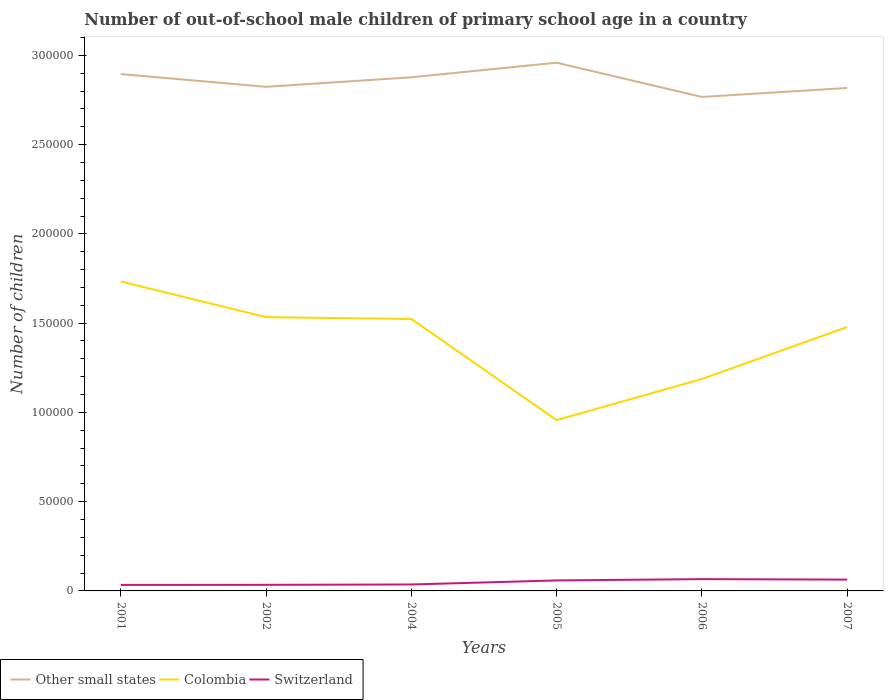How many different coloured lines are there?
Offer a terse response. 3. Is the number of lines equal to the number of legend labels?
Give a very brief answer. Yes. Across all years, what is the maximum number of out-of-school male children in Colombia?
Provide a short and direct response. 9.57e+04. What is the total number of out-of-school male children in Colombia in the graph?
Your response must be concise. 5551. What is the difference between the highest and the second highest number of out-of-school male children in Other small states?
Offer a very short reply. 1.92e+04. How many lines are there?
Provide a succinct answer. 3. How many years are there in the graph?
Give a very brief answer. 6. What is the difference between two consecutive major ticks on the Y-axis?
Make the answer very short. 5.00e+04. Are the values on the major ticks of Y-axis written in scientific E-notation?
Your response must be concise. No. Does the graph contain any zero values?
Your answer should be compact. No. How many legend labels are there?
Offer a terse response. 3. What is the title of the graph?
Offer a terse response. Number of out-of-school male children of primary school age in a country. Does "Lithuania" appear as one of the legend labels in the graph?
Keep it short and to the point. No. What is the label or title of the X-axis?
Ensure brevity in your answer.  Years. What is the label or title of the Y-axis?
Give a very brief answer. Number of children. What is the Number of children in Other small states in 2001?
Offer a terse response. 2.90e+05. What is the Number of children of Colombia in 2001?
Offer a very short reply. 1.73e+05. What is the Number of children of Switzerland in 2001?
Provide a succinct answer. 3363. What is the Number of children in Other small states in 2002?
Keep it short and to the point. 2.82e+05. What is the Number of children in Colombia in 2002?
Your answer should be very brief. 1.53e+05. What is the Number of children in Switzerland in 2002?
Make the answer very short. 3410. What is the Number of children in Other small states in 2004?
Offer a very short reply. 2.88e+05. What is the Number of children in Colombia in 2004?
Your response must be concise. 1.52e+05. What is the Number of children in Switzerland in 2004?
Keep it short and to the point. 3605. What is the Number of children of Other small states in 2005?
Offer a terse response. 2.96e+05. What is the Number of children of Colombia in 2005?
Make the answer very short. 9.57e+04. What is the Number of children of Switzerland in 2005?
Offer a very short reply. 5885. What is the Number of children of Other small states in 2006?
Make the answer very short. 2.77e+05. What is the Number of children of Colombia in 2006?
Provide a short and direct response. 1.19e+05. What is the Number of children of Switzerland in 2006?
Offer a terse response. 6611. What is the Number of children in Other small states in 2007?
Provide a succinct answer. 2.82e+05. What is the Number of children in Colombia in 2007?
Offer a very short reply. 1.48e+05. What is the Number of children in Switzerland in 2007?
Your answer should be very brief. 6335. Across all years, what is the maximum Number of children of Other small states?
Your answer should be compact. 2.96e+05. Across all years, what is the maximum Number of children of Colombia?
Offer a very short reply. 1.73e+05. Across all years, what is the maximum Number of children in Switzerland?
Ensure brevity in your answer.  6611. Across all years, what is the minimum Number of children in Other small states?
Provide a succinct answer. 2.77e+05. Across all years, what is the minimum Number of children of Colombia?
Your answer should be very brief. 9.57e+04. Across all years, what is the minimum Number of children in Switzerland?
Make the answer very short. 3363. What is the total Number of children of Other small states in the graph?
Provide a short and direct response. 1.71e+06. What is the total Number of children in Colombia in the graph?
Offer a terse response. 8.41e+05. What is the total Number of children of Switzerland in the graph?
Keep it short and to the point. 2.92e+04. What is the difference between the Number of children of Other small states in 2001 and that in 2002?
Ensure brevity in your answer.  7131. What is the difference between the Number of children of Colombia in 2001 and that in 2002?
Your answer should be very brief. 2.00e+04. What is the difference between the Number of children of Switzerland in 2001 and that in 2002?
Ensure brevity in your answer.  -47. What is the difference between the Number of children in Other small states in 2001 and that in 2004?
Provide a succinct answer. 1800. What is the difference between the Number of children of Colombia in 2001 and that in 2004?
Ensure brevity in your answer.  2.10e+04. What is the difference between the Number of children of Switzerland in 2001 and that in 2004?
Give a very brief answer. -242. What is the difference between the Number of children in Other small states in 2001 and that in 2005?
Keep it short and to the point. -6383. What is the difference between the Number of children in Colombia in 2001 and that in 2005?
Give a very brief answer. 7.77e+04. What is the difference between the Number of children of Switzerland in 2001 and that in 2005?
Keep it short and to the point. -2522. What is the difference between the Number of children of Other small states in 2001 and that in 2006?
Provide a succinct answer. 1.28e+04. What is the difference between the Number of children in Colombia in 2001 and that in 2006?
Your answer should be very brief. 5.46e+04. What is the difference between the Number of children in Switzerland in 2001 and that in 2006?
Provide a succinct answer. -3248. What is the difference between the Number of children in Other small states in 2001 and that in 2007?
Your answer should be compact. 7787. What is the difference between the Number of children of Colombia in 2001 and that in 2007?
Your response must be concise. 2.56e+04. What is the difference between the Number of children of Switzerland in 2001 and that in 2007?
Keep it short and to the point. -2972. What is the difference between the Number of children in Other small states in 2002 and that in 2004?
Offer a very short reply. -5331. What is the difference between the Number of children in Colombia in 2002 and that in 2004?
Provide a short and direct response. 1021. What is the difference between the Number of children in Switzerland in 2002 and that in 2004?
Offer a very short reply. -195. What is the difference between the Number of children in Other small states in 2002 and that in 2005?
Your answer should be very brief. -1.35e+04. What is the difference between the Number of children in Colombia in 2002 and that in 2005?
Ensure brevity in your answer.  5.77e+04. What is the difference between the Number of children in Switzerland in 2002 and that in 2005?
Offer a terse response. -2475. What is the difference between the Number of children in Other small states in 2002 and that in 2006?
Keep it short and to the point. 5676. What is the difference between the Number of children of Colombia in 2002 and that in 2006?
Give a very brief answer. 3.46e+04. What is the difference between the Number of children in Switzerland in 2002 and that in 2006?
Make the answer very short. -3201. What is the difference between the Number of children of Other small states in 2002 and that in 2007?
Offer a terse response. 656. What is the difference between the Number of children of Colombia in 2002 and that in 2007?
Offer a terse response. 5551. What is the difference between the Number of children of Switzerland in 2002 and that in 2007?
Your answer should be compact. -2925. What is the difference between the Number of children of Other small states in 2004 and that in 2005?
Offer a terse response. -8183. What is the difference between the Number of children in Colombia in 2004 and that in 2005?
Make the answer very short. 5.67e+04. What is the difference between the Number of children of Switzerland in 2004 and that in 2005?
Your answer should be very brief. -2280. What is the difference between the Number of children of Other small states in 2004 and that in 2006?
Keep it short and to the point. 1.10e+04. What is the difference between the Number of children in Colombia in 2004 and that in 2006?
Your answer should be compact. 3.36e+04. What is the difference between the Number of children of Switzerland in 2004 and that in 2006?
Make the answer very short. -3006. What is the difference between the Number of children in Other small states in 2004 and that in 2007?
Offer a terse response. 5987. What is the difference between the Number of children in Colombia in 2004 and that in 2007?
Your response must be concise. 4530. What is the difference between the Number of children of Switzerland in 2004 and that in 2007?
Keep it short and to the point. -2730. What is the difference between the Number of children in Other small states in 2005 and that in 2006?
Your answer should be compact. 1.92e+04. What is the difference between the Number of children of Colombia in 2005 and that in 2006?
Make the answer very short. -2.30e+04. What is the difference between the Number of children of Switzerland in 2005 and that in 2006?
Your answer should be compact. -726. What is the difference between the Number of children of Other small states in 2005 and that in 2007?
Provide a succinct answer. 1.42e+04. What is the difference between the Number of children of Colombia in 2005 and that in 2007?
Make the answer very short. -5.21e+04. What is the difference between the Number of children of Switzerland in 2005 and that in 2007?
Offer a terse response. -450. What is the difference between the Number of children in Other small states in 2006 and that in 2007?
Ensure brevity in your answer.  -5020. What is the difference between the Number of children of Colombia in 2006 and that in 2007?
Ensure brevity in your answer.  -2.91e+04. What is the difference between the Number of children in Switzerland in 2006 and that in 2007?
Keep it short and to the point. 276. What is the difference between the Number of children of Other small states in 2001 and the Number of children of Colombia in 2002?
Offer a very short reply. 1.36e+05. What is the difference between the Number of children in Other small states in 2001 and the Number of children in Switzerland in 2002?
Provide a short and direct response. 2.86e+05. What is the difference between the Number of children in Colombia in 2001 and the Number of children in Switzerland in 2002?
Your response must be concise. 1.70e+05. What is the difference between the Number of children of Other small states in 2001 and the Number of children of Colombia in 2004?
Your answer should be compact. 1.37e+05. What is the difference between the Number of children in Other small states in 2001 and the Number of children in Switzerland in 2004?
Provide a succinct answer. 2.86e+05. What is the difference between the Number of children of Colombia in 2001 and the Number of children of Switzerland in 2004?
Offer a very short reply. 1.70e+05. What is the difference between the Number of children in Other small states in 2001 and the Number of children in Colombia in 2005?
Ensure brevity in your answer.  1.94e+05. What is the difference between the Number of children of Other small states in 2001 and the Number of children of Switzerland in 2005?
Offer a very short reply. 2.84e+05. What is the difference between the Number of children of Colombia in 2001 and the Number of children of Switzerland in 2005?
Your answer should be compact. 1.67e+05. What is the difference between the Number of children in Other small states in 2001 and the Number of children in Colombia in 2006?
Provide a succinct answer. 1.71e+05. What is the difference between the Number of children in Other small states in 2001 and the Number of children in Switzerland in 2006?
Provide a short and direct response. 2.83e+05. What is the difference between the Number of children in Colombia in 2001 and the Number of children in Switzerland in 2006?
Your answer should be compact. 1.67e+05. What is the difference between the Number of children in Other small states in 2001 and the Number of children in Colombia in 2007?
Your answer should be very brief. 1.42e+05. What is the difference between the Number of children of Other small states in 2001 and the Number of children of Switzerland in 2007?
Give a very brief answer. 2.83e+05. What is the difference between the Number of children in Colombia in 2001 and the Number of children in Switzerland in 2007?
Provide a short and direct response. 1.67e+05. What is the difference between the Number of children of Other small states in 2002 and the Number of children of Colombia in 2004?
Offer a very short reply. 1.30e+05. What is the difference between the Number of children of Other small states in 2002 and the Number of children of Switzerland in 2004?
Give a very brief answer. 2.79e+05. What is the difference between the Number of children in Colombia in 2002 and the Number of children in Switzerland in 2004?
Provide a succinct answer. 1.50e+05. What is the difference between the Number of children in Other small states in 2002 and the Number of children in Colombia in 2005?
Your answer should be compact. 1.87e+05. What is the difference between the Number of children in Other small states in 2002 and the Number of children in Switzerland in 2005?
Your answer should be very brief. 2.76e+05. What is the difference between the Number of children of Colombia in 2002 and the Number of children of Switzerland in 2005?
Give a very brief answer. 1.47e+05. What is the difference between the Number of children of Other small states in 2002 and the Number of children of Colombia in 2006?
Make the answer very short. 1.64e+05. What is the difference between the Number of children of Other small states in 2002 and the Number of children of Switzerland in 2006?
Make the answer very short. 2.76e+05. What is the difference between the Number of children in Colombia in 2002 and the Number of children in Switzerland in 2006?
Give a very brief answer. 1.47e+05. What is the difference between the Number of children in Other small states in 2002 and the Number of children in Colombia in 2007?
Your answer should be very brief. 1.35e+05. What is the difference between the Number of children in Other small states in 2002 and the Number of children in Switzerland in 2007?
Provide a short and direct response. 2.76e+05. What is the difference between the Number of children in Colombia in 2002 and the Number of children in Switzerland in 2007?
Your answer should be very brief. 1.47e+05. What is the difference between the Number of children in Other small states in 2004 and the Number of children in Colombia in 2005?
Your response must be concise. 1.92e+05. What is the difference between the Number of children of Other small states in 2004 and the Number of children of Switzerland in 2005?
Offer a terse response. 2.82e+05. What is the difference between the Number of children in Colombia in 2004 and the Number of children in Switzerland in 2005?
Your response must be concise. 1.46e+05. What is the difference between the Number of children in Other small states in 2004 and the Number of children in Colombia in 2006?
Keep it short and to the point. 1.69e+05. What is the difference between the Number of children in Other small states in 2004 and the Number of children in Switzerland in 2006?
Ensure brevity in your answer.  2.81e+05. What is the difference between the Number of children of Colombia in 2004 and the Number of children of Switzerland in 2006?
Offer a terse response. 1.46e+05. What is the difference between the Number of children in Other small states in 2004 and the Number of children in Colombia in 2007?
Ensure brevity in your answer.  1.40e+05. What is the difference between the Number of children in Other small states in 2004 and the Number of children in Switzerland in 2007?
Provide a short and direct response. 2.81e+05. What is the difference between the Number of children of Colombia in 2004 and the Number of children of Switzerland in 2007?
Offer a terse response. 1.46e+05. What is the difference between the Number of children in Other small states in 2005 and the Number of children in Colombia in 2006?
Give a very brief answer. 1.77e+05. What is the difference between the Number of children of Other small states in 2005 and the Number of children of Switzerland in 2006?
Provide a short and direct response. 2.89e+05. What is the difference between the Number of children in Colombia in 2005 and the Number of children in Switzerland in 2006?
Keep it short and to the point. 8.91e+04. What is the difference between the Number of children of Other small states in 2005 and the Number of children of Colombia in 2007?
Your response must be concise. 1.48e+05. What is the difference between the Number of children of Other small states in 2005 and the Number of children of Switzerland in 2007?
Provide a succinct answer. 2.90e+05. What is the difference between the Number of children of Colombia in 2005 and the Number of children of Switzerland in 2007?
Provide a short and direct response. 8.93e+04. What is the difference between the Number of children in Other small states in 2006 and the Number of children in Colombia in 2007?
Your response must be concise. 1.29e+05. What is the difference between the Number of children in Other small states in 2006 and the Number of children in Switzerland in 2007?
Ensure brevity in your answer.  2.70e+05. What is the difference between the Number of children in Colombia in 2006 and the Number of children in Switzerland in 2007?
Provide a short and direct response. 1.12e+05. What is the average Number of children in Other small states per year?
Your answer should be very brief. 2.86e+05. What is the average Number of children of Colombia per year?
Make the answer very short. 1.40e+05. What is the average Number of children of Switzerland per year?
Your answer should be compact. 4868.17. In the year 2001, what is the difference between the Number of children of Other small states and Number of children of Colombia?
Give a very brief answer. 1.16e+05. In the year 2001, what is the difference between the Number of children of Other small states and Number of children of Switzerland?
Give a very brief answer. 2.86e+05. In the year 2001, what is the difference between the Number of children of Colombia and Number of children of Switzerland?
Keep it short and to the point. 1.70e+05. In the year 2002, what is the difference between the Number of children of Other small states and Number of children of Colombia?
Provide a short and direct response. 1.29e+05. In the year 2002, what is the difference between the Number of children of Other small states and Number of children of Switzerland?
Offer a very short reply. 2.79e+05. In the year 2002, what is the difference between the Number of children in Colombia and Number of children in Switzerland?
Give a very brief answer. 1.50e+05. In the year 2004, what is the difference between the Number of children of Other small states and Number of children of Colombia?
Your answer should be compact. 1.35e+05. In the year 2004, what is the difference between the Number of children of Other small states and Number of children of Switzerland?
Offer a very short reply. 2.84e+05. In the year 2004, what is the difference between the Number of children of Colombia and Number of children of Switzerland?
Provide a short and direct response. 1.49e+05. In the year 2005, what is the difference between the Number of children in Other small states and Number of children in Colombia?
Give a very brief answer. 2.00e+05. In the year 2005, what is the difference between the Number of children of Other small states and Number of children of Switzerland?
Make the answer very short. 2.90e+05. In the year 2005, what is the difference between the Number of children of Colombia and Number of children of Switzerland?
Keep it short and to the point. 8.98e+04. In the year 2006, what is the difference between the Number of children in Other small states and Number of children in Colombia?
Ensure brevity in your answer.  1.58e+05. In the year 2006, what is the difference between the Number of children in Other small states and Number of children in Switzerland?
Give a very brief answer. 2.70e+05. In the year 2006, what is the difference between the Number of children of Colombia and Number of children of Switzerland?
Offer a terse response. 1.12e+05. In the year 2007, what is the difference between the Number of children of Other small states and Number of children of Colombia?
Your response must be concise. 1.34e+05. In the year 2007, what is the difference between the Number of children of Other small states and Number of children of Switzerland?
Make the answer very short. 2.75e+05. In the year 2007, what is the difference between the Number of children in Colombia and Number of children in Switzerland?
Offer a very short reply. 1.41e+05. What is the ratio of the Number of children in Other small states in 2001 to that in 2002?
Give a very brief answer. 1.03. What is the ratio of the Number of children in Colombia in 2001 to that in 2002?
Ensure brevity in your answer.  1.13. What is the ratio of the Number of children of Switzerland in 2001 to that in 2002?
Offer a very short reply. 0.99. What is the ratio of the Number of children of Colombia in 2001 to that in 2004?
Your answer should be compact. 1.14. What is the ratio of the Number of children of Switzerland in 2001 to that in 2004?
Your answer should be compact. 0.93. What is the ratio of the Number of children in Other small states in 2001 to that in 2005?
Your response must be concise. 0.98. What is the ratio of the Number of children of Colombia in 2001 to that in 2005?
Offer a terse response. 1.81. What is the ratio of the Number of children of Switzerland in 2001 to that in 2005?
Make the answer very short. 0.57. What is the ratio of the Number of children of Other small states in 2001 to that in 2006?
Your answer should be very brief. 1.05. What is the ratio of the Number of children of Colombia in 2001 to that in 2006?
Your answer should be compact. 1.46. What is the ratio of the Number of children in Switzerland in 2001 to that in 2006?
Provide a short and direct response. 0.51. What is the ratio of the Number of children in Other small states in 2001 to that in 2007?
Your answer should be compact. 1.03. What is the ratio of the Number of children in Colombia in 2001 to that in 2007?
Offer a terse response. 1.17. What is the ratio of the Number of children in Switzerland in 2001 to that in 2007?
Offer a terse response. 0.53. What is the ratio of the Number of children in Other small states in 2002 to that in 2004?
Provide a succinct answer. 0.98. What is the ratio of the Number of children in Switzerland in 2002 to that in 2004?
Your answer should be compact. 0.95. What is the ratio of the Number of children in Other small states in 2002 to that in 2005?
Provide a short and direct response. 0.95. What is the ratio of the Number of children of Colombia in 2002 to that in 2005?
Provide a short and direct response. 1.6. What is the ratio of the Number of children in Switzerland in 2002 to that in 2005?
Your response must be concise. 0.58. What is the ratio of the Number of children in Other small states in 2002 to that in 2006?
Keep it short and to the point. 1.02. What is the ratio of the Number of children in Colombia in 2002 to that in 2006?
Provide a short and direct response. 1.29. What is the ratio of the Number of children in Switzerland in 2002 to that in 2006?
Provide a succinct answer. 0.52. What is the ratio of the Number of children in Other small states in 2002 to that in 2007?
Your answer should be very brief. 1. What is the ratio of the Number of children of Colombia in 2002 to that in 2007?
Offer a terse response. 1.04. What is the ratio of the Number of children in Switzerland in 2002 to that in 2007?
Your answer should be very brief. 0.54. What is the ratio of the Number of children of Other small states in 2004 to that in 2005?
Provide a succinct answer. 0.97. What is the ratio of the Number of children in Colombia in 2004 to that in 2005?
Provide a succinct answer. 1.59. What is the ratio of the Number of children in Switzerland in 2004 to that in 2005?
Your answer should be compact. 0.61. What is the ratio of the Number of children in Other small states in 2004 to that in 2006?
Keep it short and to the point. 1.04. What is the ratio of the Number of children in Colombia in 2004 to that in 2006?
Offer a very short reply. 1.28. What is the ratio of the Number of children of Switzerland in 2004 to that in 2006?
Provide a succinct answer. 0.55. What is the ratio of the Number of children of Other small states in 2004 to that in 2007?
Offer a terse response. 1.02. What is the ratio of the Number of children in Colombia in 2004 to that in 2007?
Your answer should be compact. 1.03. What is the ratio of the Number of children of Switzerland in 2004 to that in 2007?
Ensure brevity in your answer.  0.57. What is the ratio of the Number of children of Other small states in 2005 to that in 2006?
Provide a succinct answer. 1.07. What is the ratio of the Number of children of Colombia in 2005 to that in 2006?
Provide a succinct answer. 0.81. What is the ratio of the Number of children in Switzerland in 2005 to that in 2006?
Ensure brevity in your answer.  0.89. What is the ratio of the Number of children in Other small states in 2005 to that in 2007?
Offer a very short reply. 1.05. What is the ratio of the Number of children in Colombia in 2005 to that in 2007?
Your answer should be very brief. 0.65. What is the ratio of the Number of children of Switzerland in 2005 to that in 2007?
Provide a succinct answer. 0.93. What is the ratio of the Number of children in Other small states in 2006 to that in 2007?
Your answer should be compact. 0.98. What is the ratio of the Number of children in Colombia in 2006 to that in 2007?
Keep it short and to the point. 0.8. What is the ratio of the Number of children of Switzerland in 2006 to that in 2007?
Ensure brevity in your answer.  1.04. What is the difference between the highest and the second highest Number of children in Other small states?
Your answer should be compact. 6383. What is the difference between the highest and the second highest Number of children in Colombia?
Give a very brief answer. 2.00e+04. What is the difference between the highest and the second highest Number of children of Switzerland?
Make the answer very short. 276. What is the difference between the highest and the lowest Number of children in Other small states?
Your response must be concise. 1.92e+04. What is the difference between the highest and the lowest Number of children in Colombia?
Give a very brief answer. 7.77e+04. What is the difference between the highest and the lowest Number of children of Switzerland?
Your response must be concise. 3248. 